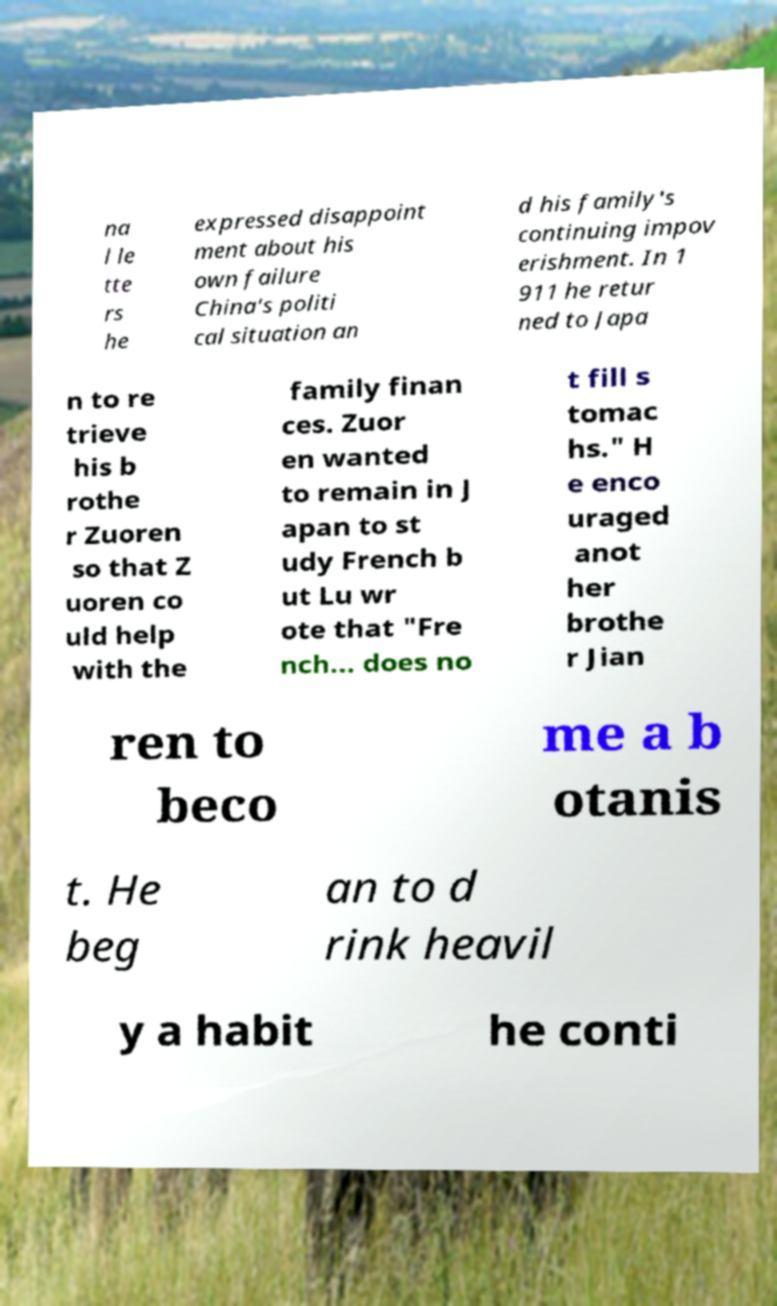Can you accurately transcribe the text from the provided image for me? na l le tte rs he expressed disappoint ment about his own failure China's politi cal situation an d his family's continuing impov erishment. In 1 911 he retur ned to Japa n to re trieve his b rothe r Zuoren so that Z uoren co uld help with the family finan ces. Zuor en wanted to remain in J apan to st udy French b ut Lu wr ote that "Fre nch... does no t fill s tomac hs." H e enco uraged anot her brothe r Jian ren to beco me a b otanis t. He beg an to d rink heavil y a habit he conti 